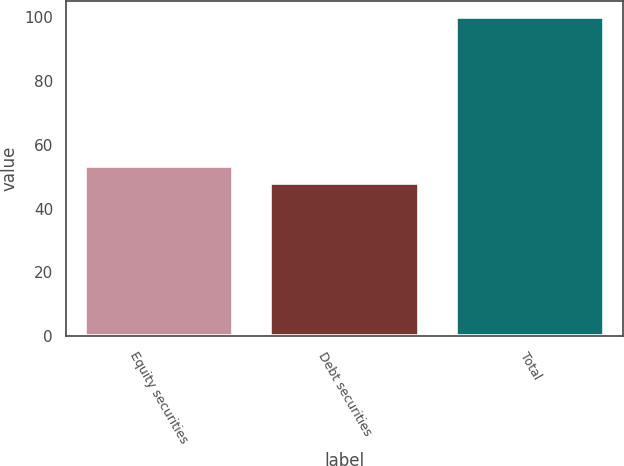Convert chart to OTSL. <chart><loc_0><loc_0><loc_500><loc_500><bar_chart><fcel>Equity securities<fcel>Debt securities<fcel>Total<nl><fcel>53.2<fcel>48<fcel>100<nl></chart> 